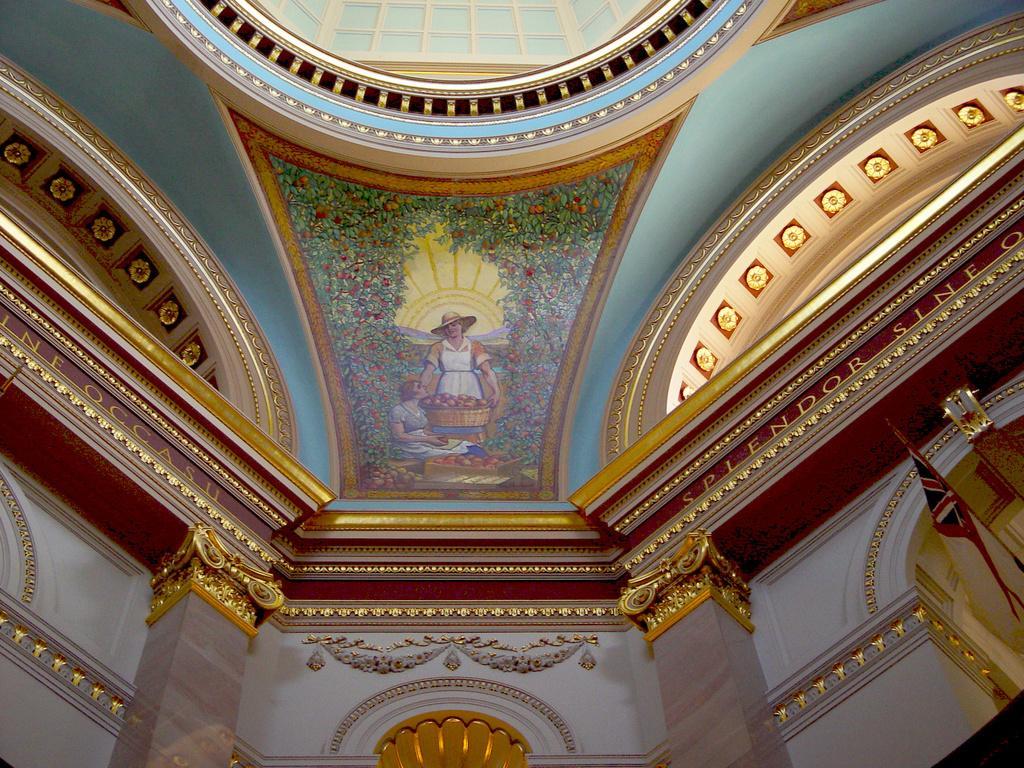Could you give a brief overview of what you see in this image? Here in this picture we can see an interior view of a building and in the middle we can see a marble stone design with trees and couple of people on that over there and on right side we can see a flag post present over there. 